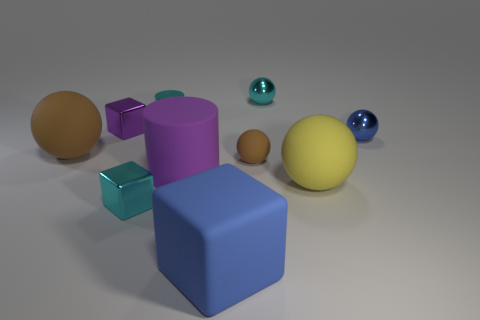Subtract all tiny brown matte spheres. How many spheres are left? 4 Subtract all yellow balls. How many balls are left? 4 Subtract 2 balls. How many balls are left? 3 Subtract all purple spheres. Subtract all yellow cylinders. How many spheres are left? 5 Subtract all cylinders. How many objects are left? 8 Subtract 0 gray cylinders. How many objects are left? 10 Subtract all cyan objects. Subtract all large purple rubber cylinders. How many objects are left? 6 Add 6 large matte cylinders. How many large matte cylinders are left? 7 Add 9 brown metallic balls. How many brown metallic balls exist? 9 